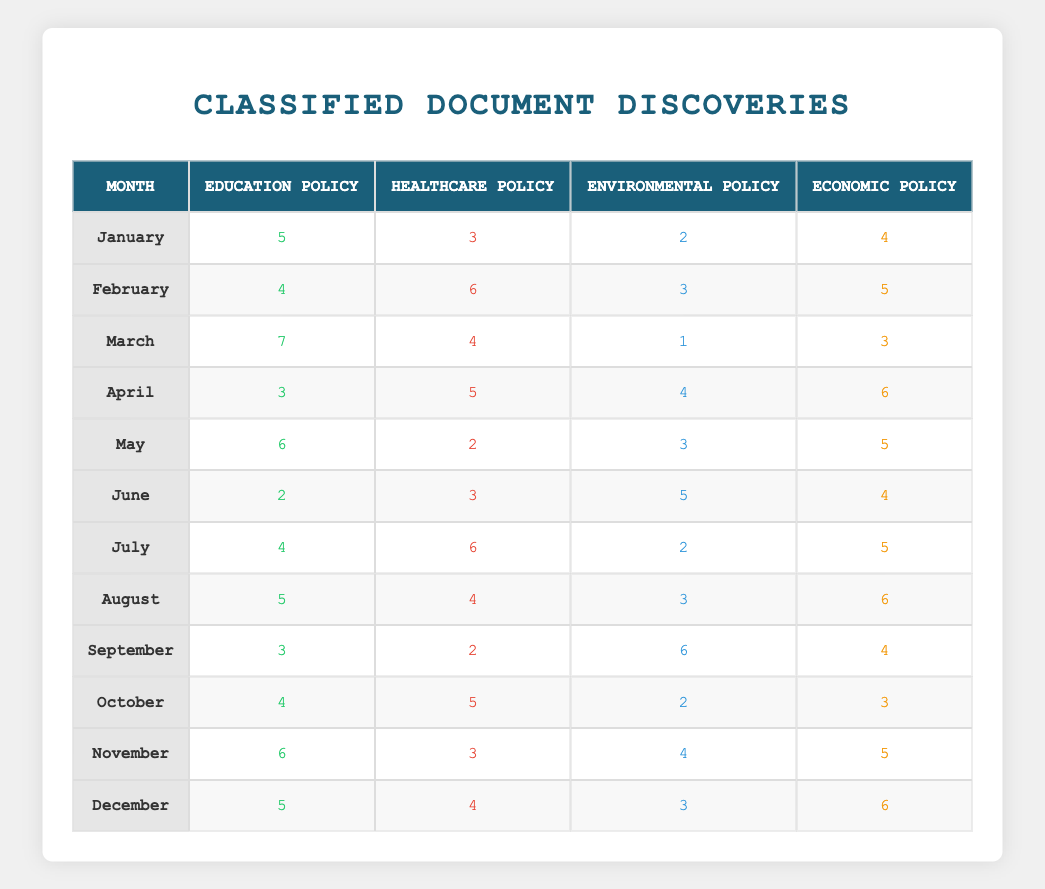What was the highest number of documents collected related to Healthcare Policy in a single month? Looking at each month, the counts for Healthcare Policy are: January (3), February (6), March (4), April (5), May (2), June (3), July (6), August (4), September (2), October (5), November (3), December (4). The highest is 6, which occurred in both February and July.
Answer: 6 In which month were the fewest documents related to Environmental Policy discovered? Checking the Environmental Policy counts: January (2), February (3), March (1), April (4), May (3), June (5), July (2), August (3), September (6), October (2), November (4), December (3). The minimum is 1 in March.
Answer: March What is the total number of documents related to Education Policy found between January and June? We need to sum the counts for Education Policy from January to June: 5 (January) + 4 (February) + 7 (March) + 3 (April) + 6 (May) + 2 (June) = 27.
Answer: 27 Was the number of documents related to Economic Policy greater than the number of Healthcare Policy documents in November? In November, Economic Policy had 5 documents and Healthcare Policy had 3. Since 5 is greater than 3, the answer is yes.
Answer: Yes Which month had the highest total count of documents across all policies? The total count for each month is: January (5+3+2+4=14), February (4+6+3+5=18), March (7+4+1+3=15), April (3+5+4+6=18), May (6+2+3+5=16), June (2+3+5+4=14), July (4+6+2+5=17), August (5+4+3+6=18), September (3+2+6+4=15), October (4+5+2+3=14), November (6+3+4+5=18), December (5+4+3+6=18). The highest total is 18 in February, April, August, November, and December.
Answer: 18 How many more documents related to Economic Policy were discovered in December compared to January? Economic Policy had 6 documents in December and 4 in January. The difference is 6 - 4 = 2.
Answer: 2 What was the average number of Education Policy documents discovered per month throughout the year? The counts for Education Policy are: 5, 4, 7, 3, 6, 2, 4, 5, 3, 4, 6, and 5. Summing these gives 5+4+7+3+6+2+4+5+3+4+6+5 = 60. There are 12 months, so the average is 60/12 = 5.
Answer: 5 Did any month have the same count for both Environmental and Economic Policy? Checking each month: January (2, 4), February (3, 5), March (1, 3), April (4, 6), May (3, 5), June (5, 4), July (2, 5), August (3, 6), September (6, 4), October (2, 3), November (4, 5), December (3, 6). No month matches.
Answer: No 